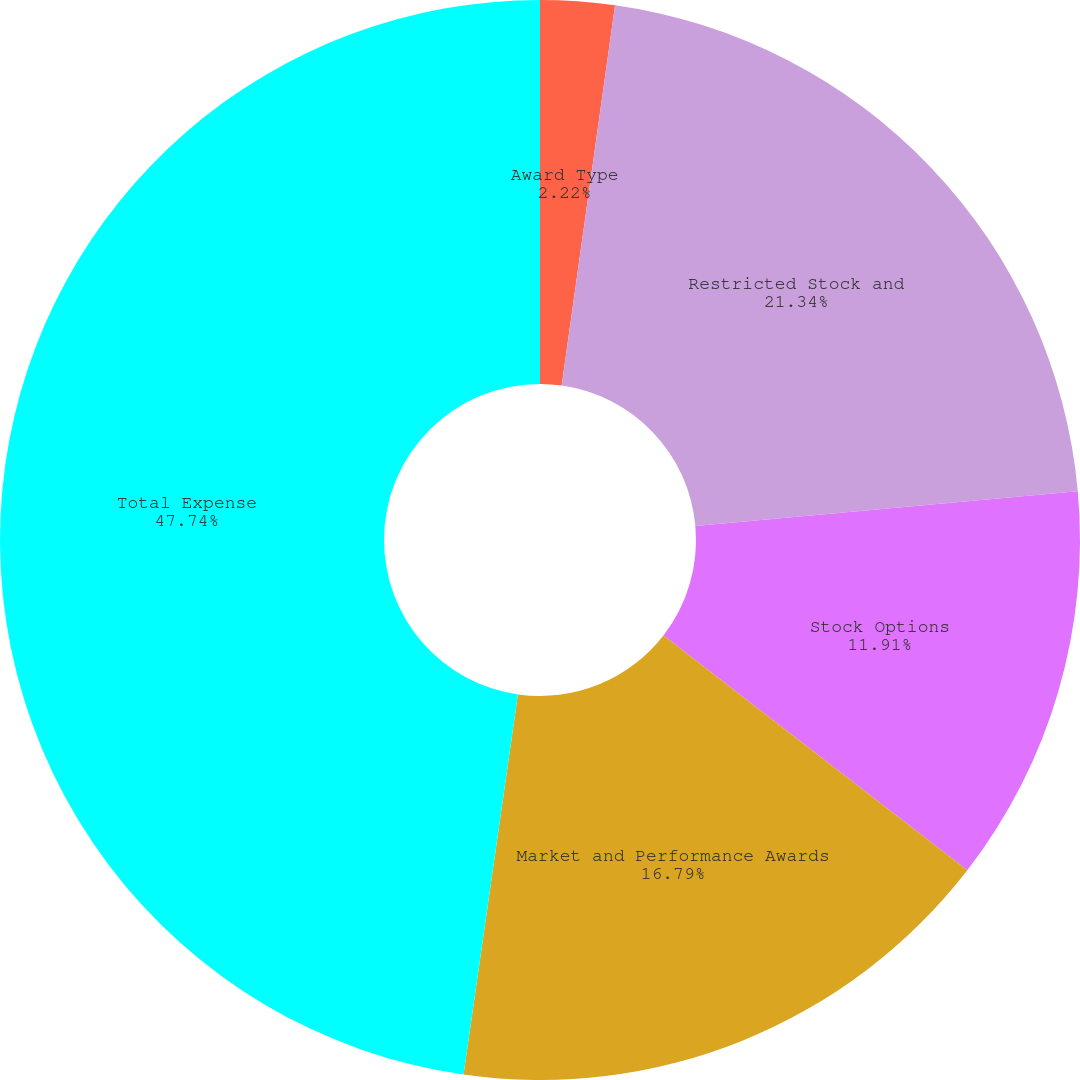Convert chart. <chart><loc_0><loc_0><loc_500><loc_500><pie_chart><fcel>Award Type<fcel>Restricted Stock and<fcel>Stock Options<fcel>Market and Performance Awards<fcel>Total Expense<nl><fcel>2.22%<fcel>21.34%<fcel>11.91%<fcel>16.79%<fcel>47.74%<nl></chart> 